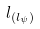Convert formula to latex. <formula><loc_0><loc_0><loc_500><loc_500>l _ { ( l _ { \psi } ) }</formula> 